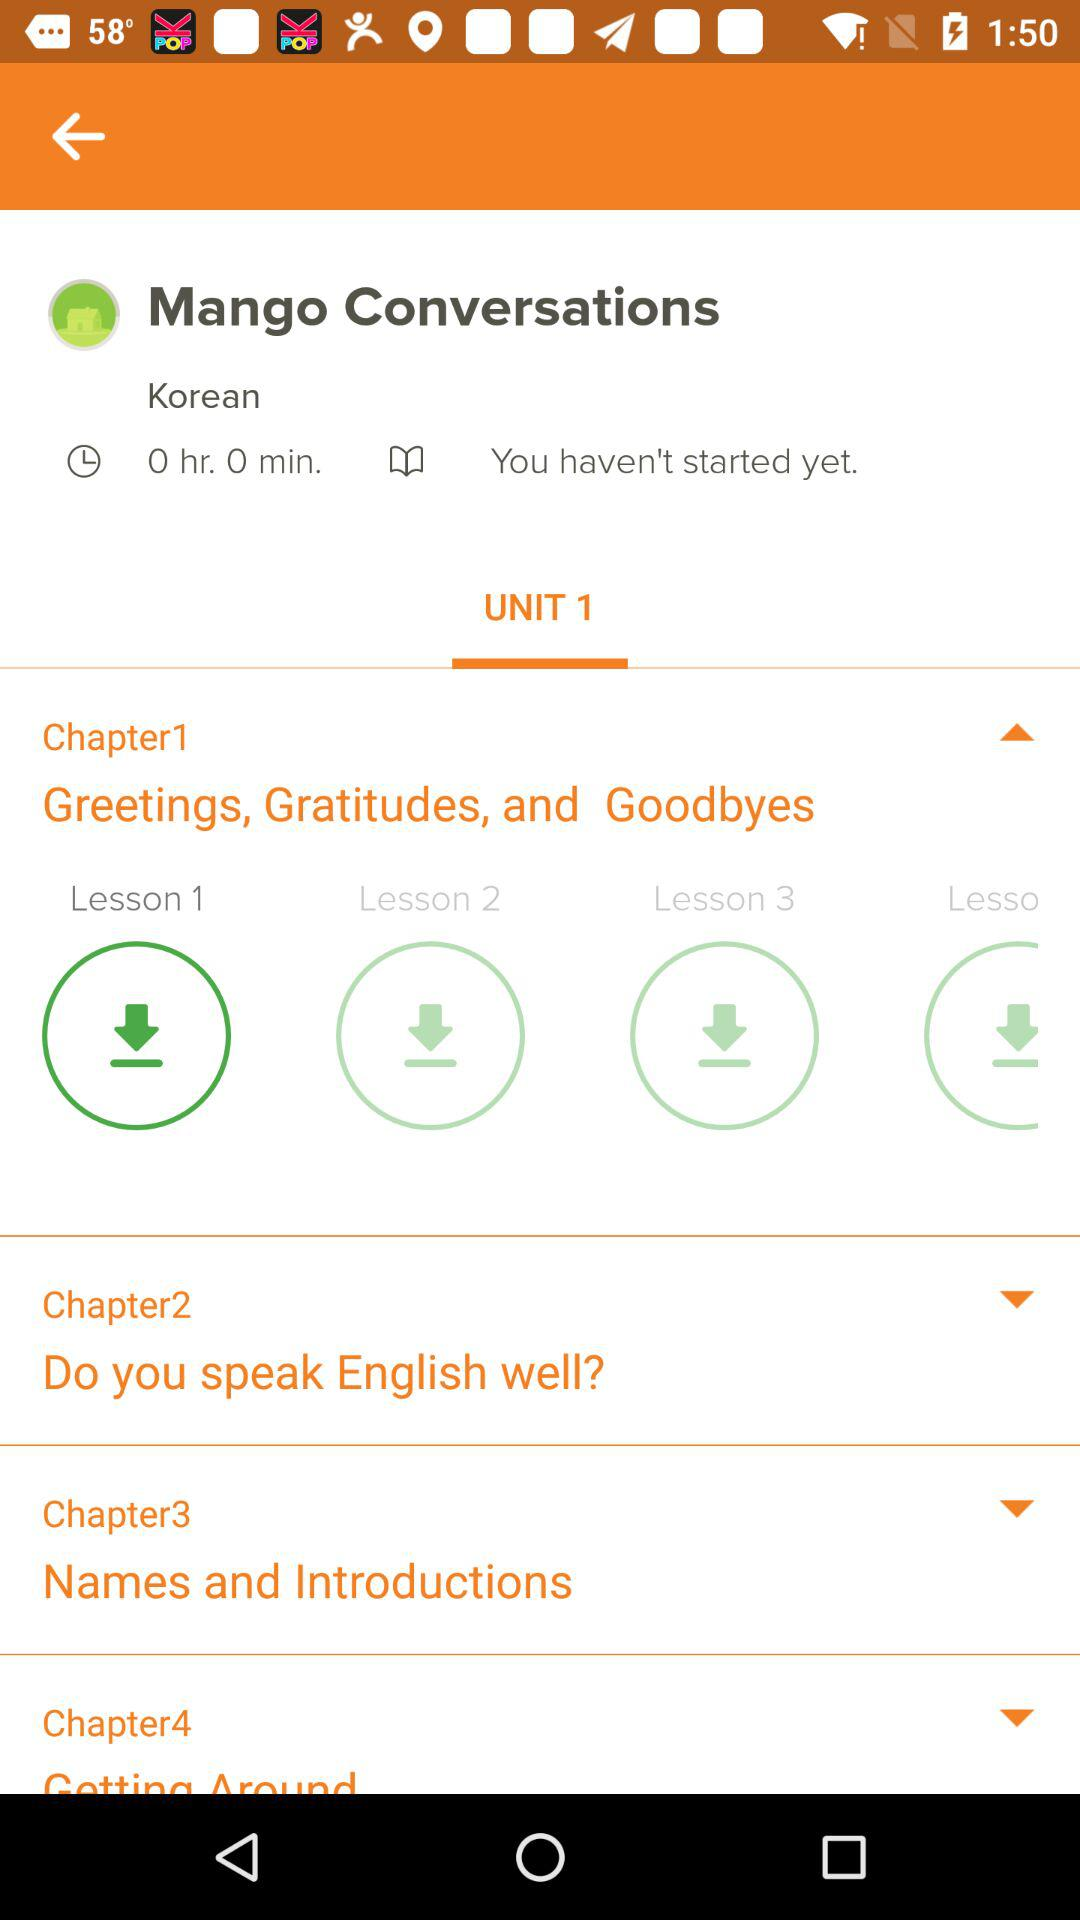What is the name of Chapter 1? Chapter 1 is titled 'Greetings, Gratitudes, and Goodbyes', which suggests that this chapter likely focuses on social expressions used to greet someone, express thanks, or bid farewell in a conversational setting. 